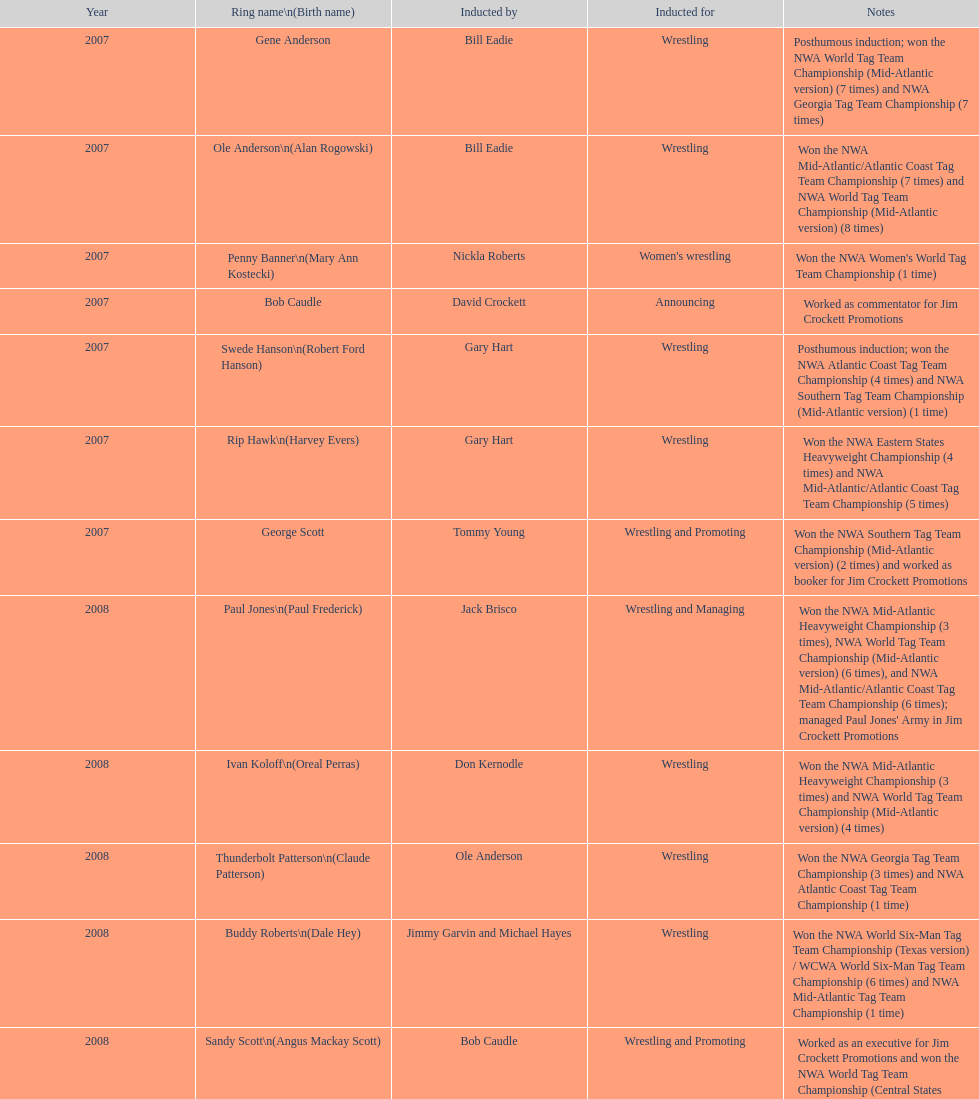How many members were incorporated for proclamation? 2. 